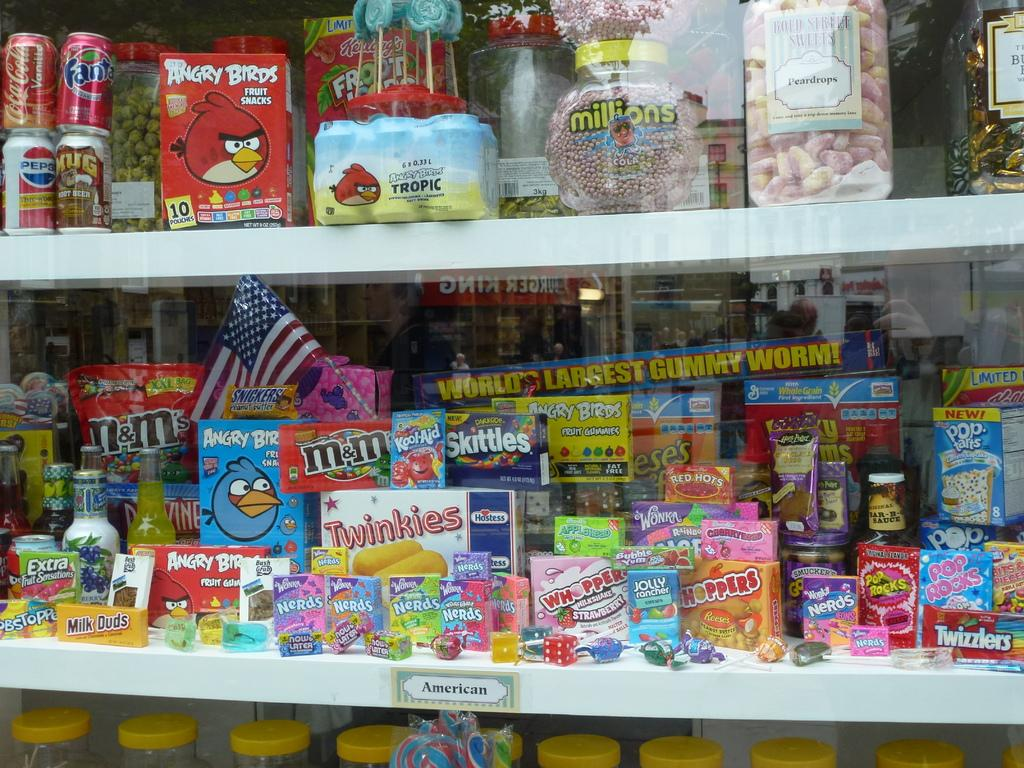<image>
Render a clear and concise summary of the photo. Grocery store shelves display many candies, including Darkside Skittles, Red Hots, and Angry Bird Fruit Snacks. 